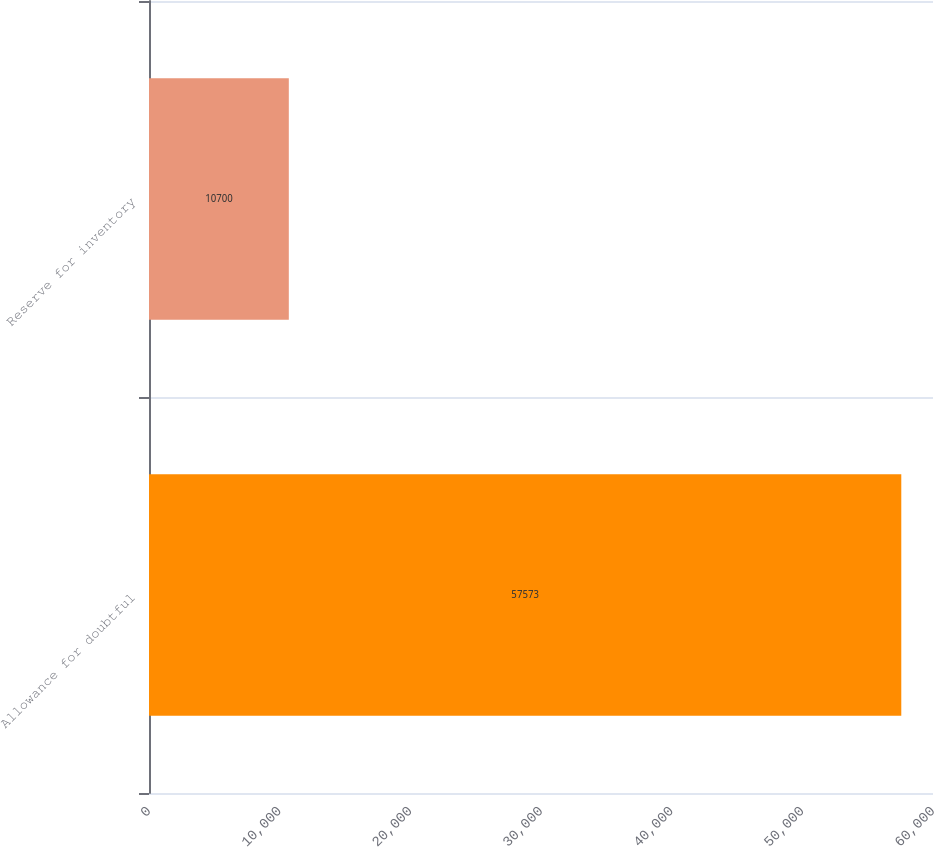<chart> <loc_0><loc_0><loc_500><loc_500><bar_chart><fcel>Allowance for doubtful<fcel>Reserve for inventory<nl><fcel>57573<fcel>10700<nl></chart> 